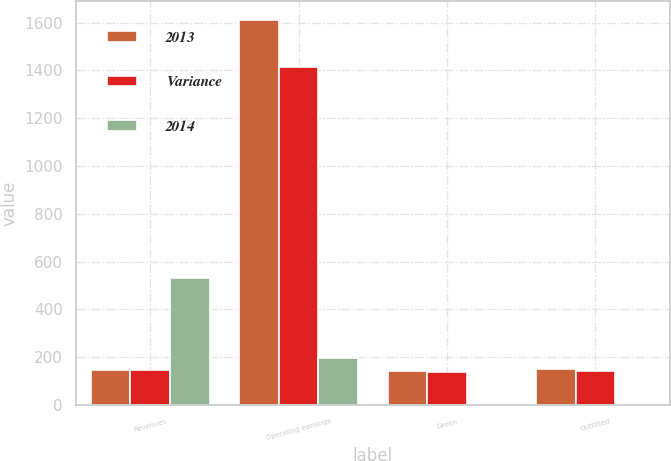Convert chart to OTSL. <chart><loc_0><loc_0><loc_500><loc_500><stacked_bar_chart><ecel><fcel>Revenues<fcel>Operating earnings<fcel>Green<fcel>Outfitted<nl><fcel>2013<fcel>147<fcel>1611<fcel>144<fcel>150<nl><fcel>Variance<fcel>147<fcel>1416<fcel>139<fcel>144<nl><fcel>2014<fcel>531<fcel>195<fcel>5<fcel>6<nl></chart> 